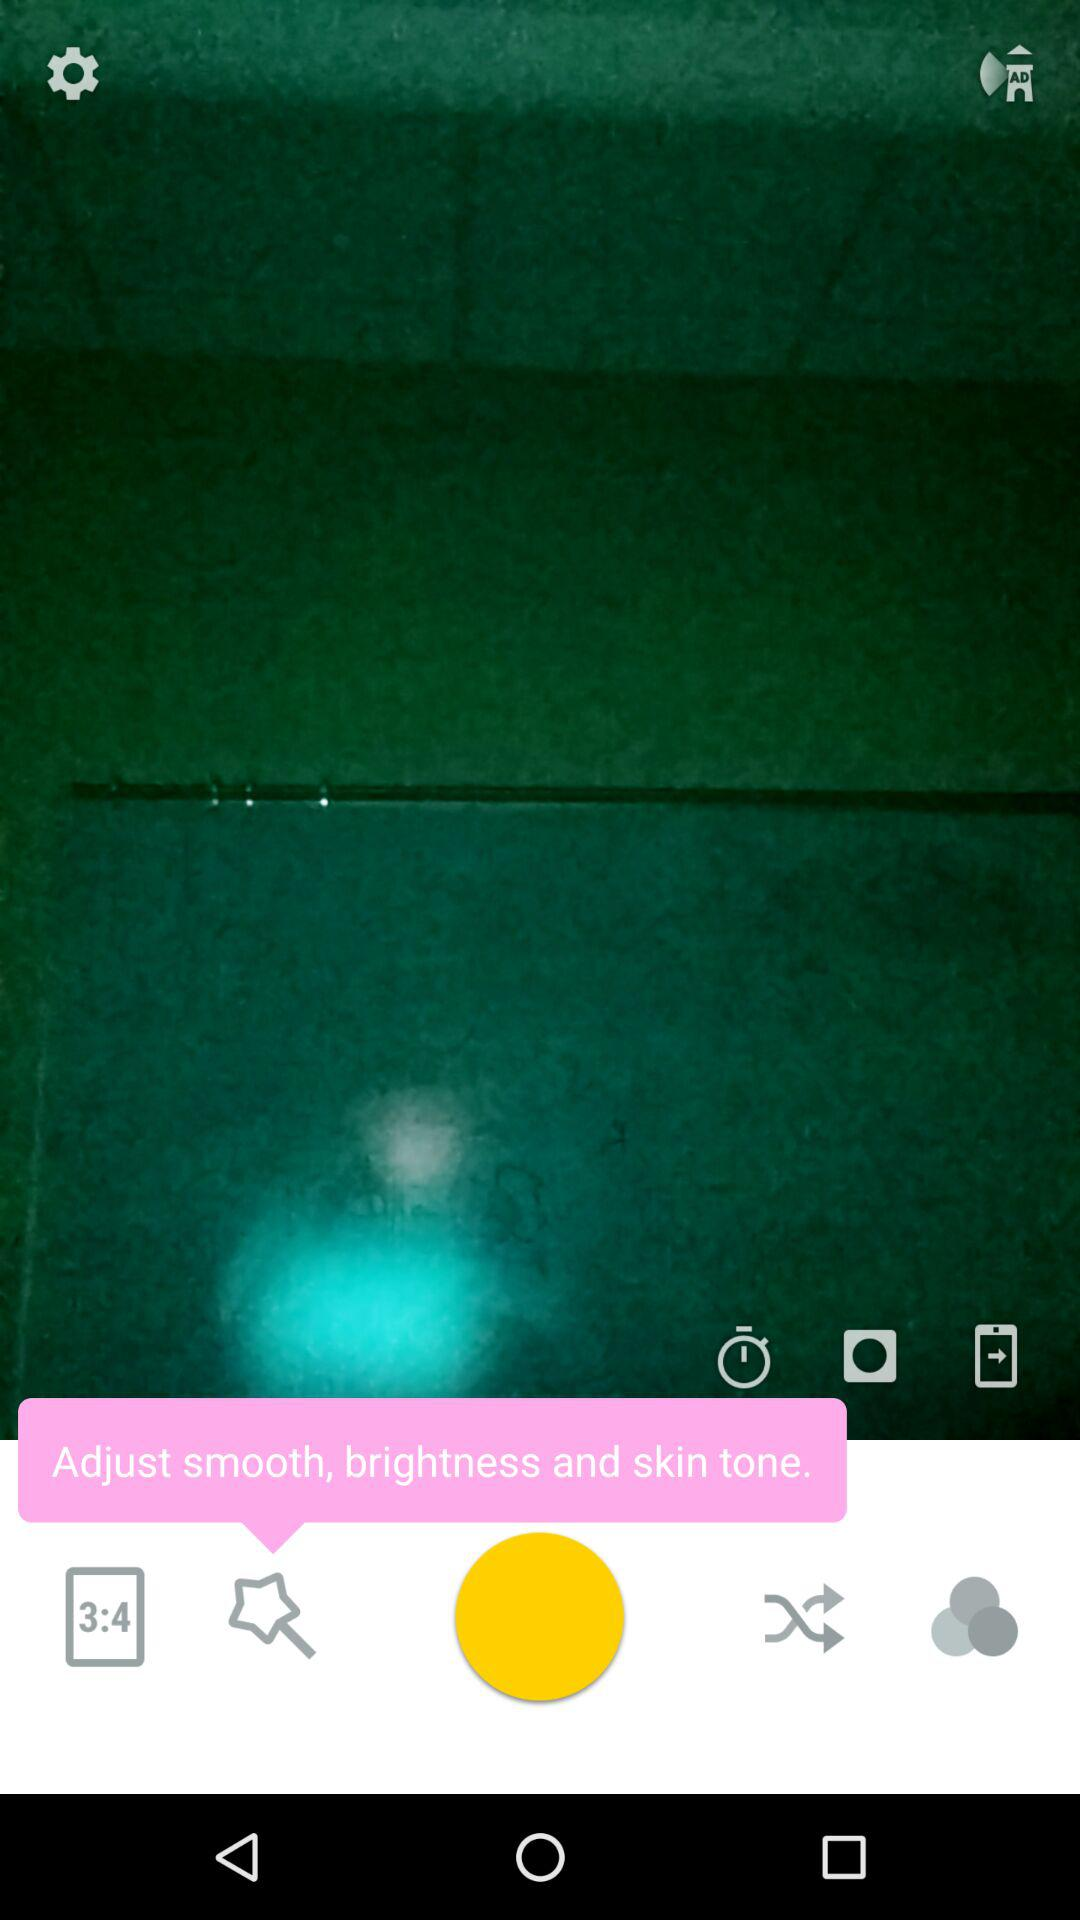Which frame ratio is selected? The selected frame ratio is 3:4. 